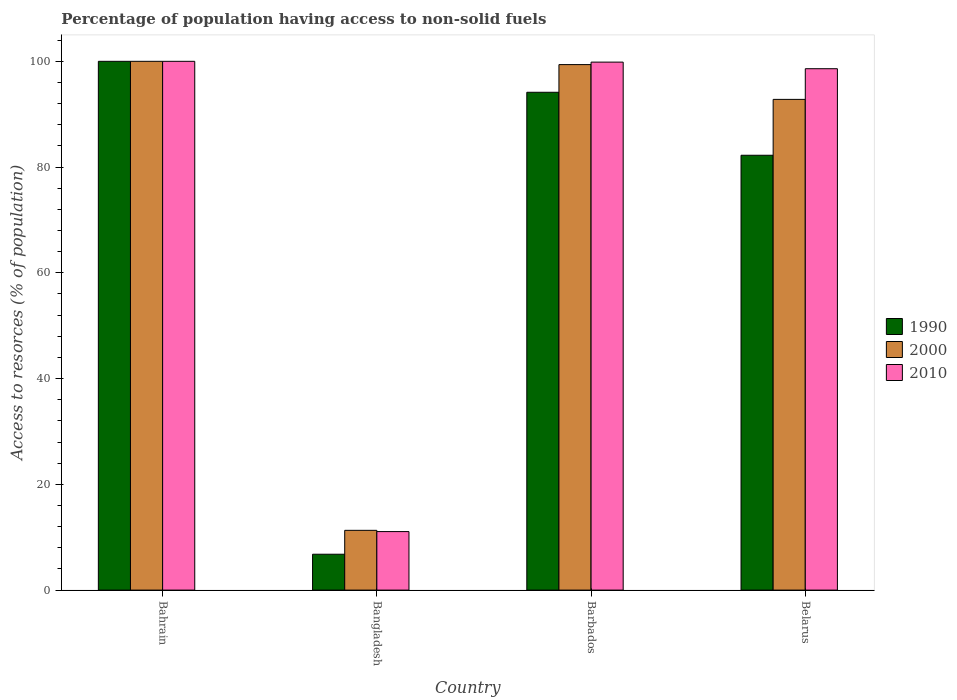How many different coloured bars are there?
Offer a very short reply. 3. How many groups of bars are there?
Provide a succinct answer. 4. How many bars are there on the 3rd tick from the left?
Offer a very short reply. 3. How many bars are there on the 2nd tick from the right?
Your answer should be compact. 3. What is the label of the 3rd group of bars from the left?
Make the answer very short. Barbados. What is the percentage of population having access to non-solid fuels in 2010 in Barbados?
Your answer should be very brief. 99.85. Across all countries, what is the minimum percentage of population having access to non-solid fuels in 1990?
Offer a terse response. 6.78. In which country was the percentage of population having access to non-solid fuels in 2010 maximum?
Your answer should be very brief. Bahrain. What is the total percentage of population having access to non-solid fuels in 1990 in the graph?
Ensure brevity in your answer.  283.16. What is the difference between the percentage of population having access to non-solid fuels in 2000 in Bangladesh and that in Belarus?
Make the answer very short. -81.5. What is the difference between the percentage of population having access to non-solid fuels in 2010 in Bahrain and the percentage of population having access to non-solid fuels in 1990 in Belarus?
Give a very brief answer. 17.76. What is the average percentage of population having access to non-solid fuels in 2010 per country?
Your answer should be compact. 77.38. What is the difference between the percentage of population having access to non-solid fuels of/in 1990 and percentage of population having access to non-solid fuels of/in 2000 in Bangladesh?
Offer a very short reply. -4.52. What is the ratio of the percentage of population having access to non-solid fuels in 1990 in Bangladesh to that in Barbados?
Your answer should be very brief. 0.07. Is the percentage of population having access to non-solid fuels in 1990 in Barbados less than that in Belarus?
Your answer should be very brief. No. Is the difference between the percentage of population having access to non-solid fuels in 1990 in Bahrain and Barbados greater than the difference between the percentage of population having access to non-solid fuels in 2000 in Bahrain and Barbados?
Make the answer very short. Yes. What is the difference between the highest and the second highest percentage of population having access to non-solid fuels in 1990?
Provide a short and direct response. -17.76. What is the difference between the highest and the lowest percentage of population having access to non-solid fuels in 2000?
Provide a succinct answer. 88.7. In how many countries, is the percentage of population having access to non-solid fuels in 2000 greater than the average percentage of population having access to non-solid fuels in 2000 taken over all countries?
Give a very brief answer. 3. What does the 2nd bar from the left in Barbados represents?
Your answer should be compact. 2000. Is it the case that in every country, the sum of the percentage of population having access to non-solid fuels in 2010 and percentage of population having access to non-solid fuels in 2000 is greater than the percentage of population having access to non-solid fuels in 1990?
Your answer should be compact. Yes. Are all the bars in the graph horizontal?
Your answer should be compact. No. How many countries are there in the graph?
Offer a terse response. 4. Does the graph contain any zero values?
Provide a succinct answer. No. What is the title of the graph?
Make the answer very short. Percentage of population having access to non-solid fuels. What is the label or title of the X-axis?
Provide a succinct answer. Country. What is the label or title of the Y-axis?
Your answer should be very brief. Access to resorces (% of population). What is the Access to resorces (% of population) of 2010 in Bahrain?
Provide a succinct answer. 100. What is the Access to resorces (% of population) in 1990 in Bangladesh?
Your answer should be very brief. 6.78. What is the Access to resorces (% of population) of 2000 in Bangladesh?
Your answer should be very brief. 11.3. What is the Access to resorces (% of population) in 2010 in Bangladesh?
Give a very brief answer. 11.07. What is the Access to resorces (% of population) of 1990 in Barbados?
Your answer should be very brief. 94.14. What is the Access to resorces (% of population) in 2000 in Barbados?
Your response must be concise. 99.38. What is the Access to resorces (% of population) in 2010 in Barbados?
Provide a short and direct response. 99.85. What is the Access to resorces (% of population) of 1990 in Belarus?
Give a very brief answer. 82.24. What is the Access to resorces (% of population) of 2000 in Belarus?
Ensure brevity in your answer.  92.8. What is the Access to resorces (% of population) of 2010 in Belarus?
Make the answer very short. 98.6. Across all countries, what is the minimum Access to resorces (% of population) in 1990?
Ensure brevity in your answer.  6.78. Across all countries, what is the minimum Access to resorces (% of population) in 2000?
Your response must be concise. 11.3. Across all countries, what is the minimum Access to resorces (% of population) of 2010?
Provide a succinct answer. 11.07. What is the total Access to resorces (% of population) of 1990 in the graph?
Your answer should be very brief. 283.16. What is the total Access to resorces (% of population) in 2000 in the graph?
Your answer should be very brief. 303.48. What is the total Access to resorces (% of population) in 2010 in the graph?
Your answer should be very brief. 309.51. What is the difference between the Access to resorces (% of population) in 1990 in Bahrain and that in Bangladesh?
Make the answer very short. 93.22. What is the difference between the Access to resorces (% of population) of 2000 in Bahrain and that in Bangladesh?
Offer a very short reply. 88.7. What is the difference between the Access to resorces (% of population) in 2010 in Bahrain and that in Bangladesh?
Make the answer very short. 88.93. What is the difference between the Access to resorces (% of population) in 1990 in Bahrain and that in Barbados?
Your answer should be very brief. 5.86. What is the difference between the Access to resorces (% of population) of 2000 in Bahrain and that in Barbados?
Give a very brief answer. 0.62. What is the difference between the Access to resorces (% of population) of 2010 in Bahrain and that in Barbados?
Offer a terse response. 0.15. What is the difference between the Access to resorces (% of population) in 1990 in Bahrain and that in Belarus?
Offer a very short reply. 17.76. What is the difference between the Access to resorces (% of population) in 2000 in Bahrain and that in Belarus?
Make the answer very short. 7.2. What is the difference between the Access to resorces (% of population) in 2010 in Bahrain and that in Belarus?
Provide a short and direct response. 1.4. What is the difference between the Access to resorces (% of population) of 1990 in Bangladesh and that in Barbados?
Your answer should be compact. -87.36. What is the difference between the Access to resorces (% of population) in 2000 in Bangladesh and that in Barbados?
Keep it short and to the point. -88.08. What is the difference between the Access to resorces (% of population) of 2010 in Bangladesh and that in Barbados?
Provide a short and direct response. -88.78. What is the difference between the Access to resorces (% of population) of 1990 in Bangladesh and that in Belarus?
Give a very brief answer. -75.45. What is the difference between the Access to resorces (% of population) in 2000 in Bangladesh and that in Belarus?
Offer a terse response. -81.5. What is the difference between the Access to resorces (% of population) in 2010 in Bangladesh and that in Belarus?
Give a very brief answer. -87.53. What is the difference between the Access to resorces (% of population) of 1990 in Barbados and that in Belarus?
Offer a terse response. 11.91. What is the difference between the Access to resorces (% of population) in 2000 in Barbados and that in Belarus?
Make the answer very short. 6.58. What is the difference between the Access to resorces (% of population) of 2010 in Barbados and that in Belarus?
Your answer should be very brief. 1.25. What is the difference between the Access to resorces (% of population) in 1990 in Bahrain and the Access to resorces (% of population) in 2000 in Bangladesh?
Give a very brief answer. 88.7. What is the difference between the Access to resorces (% of population) in 1990 in Bahrain and the Access to resorces (% of population) in 2010 in Bangladesh?
Your response must be concise. 88.93. What is the difference between the Access to resorces (% of population) of 2000 in Bahrain and the Access to resorces (% of population) of 2010 in Bangladesh?
Your answer should be compact. 88.93. What is the difference between the Access to resorces (% of population) in 1990 in Bahrain and the Access to resorces (% of population) in 2000 in Barbados?
Offer a terse response. 0.62. What is the difference between the Access to resorces (% of population) of 1990 in Bahrain and the Access to resorces (% of population) of 2010 in Barbados?
Your response must be concise. 0.15. What is the difference between the Access to resorces (% of population) in 2000 in Bahrain and the Access to resorces (% of population) in 2010 in Barbados?
Keep it short and to the point. 0.15. What is the difference between the Access to resorces (% of population) in 1990 in Bahrain and the Access to resorces (% of population) in 2000 in Belarus?
Your response must be concise. 7.2. What is the difference between the Access to resorces (% of population) of 1990 in Bahrain and the Access to resorces (% of population) of 2010 in Belarus?
Make the answer very short. 1.4. What is the difference between the Access to resorces (% of population) in 2000 in Bahrain and the Access to resorces (% of population) in 2010 in Belarus?
Offer a very short reply. 1.4. What is the difference between the Access to resorces (% of population) of 1990 in Bangladesh and the Access to resorces (% of population) of 2000 in Barbados?
Keep it short and to the point. -92.6. What is the difference between the Access to resorces (% of population) in 1990 in Bangladesh and the Access to resorces (% of population) in 2010 in Barbados?
Your response must be concise. -93.06. What is the difference between the Access to resorces (% of population) of 2000 in Bangladesh and the Access to resorces (% of population) of 2010 in Barbados?
Make the answer very short. -88.55. What is the difference between the Access to resorces (% of population) in 1990 in Bangladesh and the Access to resorces (% of population) in 2000 in Belarus?
Keep it short and to the point. -86.02. What is the difference between the Access to resorces (% of population) of 1990 in Bangladesh and the Access to resorces (% of population) of 2010 in Belarus?
Your response must be concise. -91.82. What is the difference between the Access to resorces (% of population) in 2000 in Bangladesh and the Access to resorces (% of population) in 2010 in Belarus?
Your response must be concise. -87.3. What is the difference between the Access to resorces (% of population) of 1990 in Barbados and the Access to resorces (% of population) of 2000 in Belarus?
Provide a succinct answer. 1.34. What is the difference between the Access to resorces (% of population) in 1990 in Barbados and the Access to resorces (% of population) in 2010 in Belarus?
Provide a succinct answer. -4.46. What is the difference between the Access to resorces (% of population) in 2000 in Barbados and the Access to resorces (% of population) in 2010 in Belarus?
Your response must be concise. 0.78. What is the average Access to resorces (% of population) in 1990 per country?
Provide a short and direct response. 70.79. What is the average Access to resorces (% of population) of 2000 per country?
Make the answer very short. 75.87. What is the average Access to resorces (% of population) in 2010 per country?
Your answer should be compact. 77.38. What is the difference between the Access to resorces (% of population) in 1990 and Access to resorces (% of population) in 2000 in Bahrain?
Offer a very short reply. 0. What is the difference between the Access to resorces (% of population) in 1990 and Access to resorces (% of population) in 2010 in Bahrain?
Offer a terse response. 0. What is the difference between the Access to resorces (% of population) in 2000 and Access to resorces (% of population) in 2010 in Bahrain?
Give a very brief answer. 0. What is the difference between the Access to resorces (% of population) in 1990 and Access to resorces (% of population) in 2000 in Bangladesh?
Give a very brief answer. -4.52. What is the difference between the Access to resorces (% of population) of 1990 and Access to resorces (% of population) of 2010 in Bangladesh?
Offer a terse response. -4.28. What is the difference between the Access to resorces (% of population) in 2000 and Access to resorces (% of population) in 2010 in Bangladesh?
Offer a terse response. 0.24. What is the difference between the Access to resorces (% of population) of 1990 and Access to resorces (% of population) of 2000 in Barbados?
Your answer should be compact. -5.23. What is the difference between the Access to resorces (% of population) in 1990 and Access to resorces (% of population) in 2010 in Barbados?
Make the answer very short. -5.7. What is the difference between the Access to resorces (% of population) of 2000 and Access to resorces (% of population) of 2010 in Barbados?
Ensure brevity in your answer.  -0.47. What is the difference between the Access to resorces (% of population) of 1990 and Access to resorces (% of population) of 2000 in Belarus?
Ensure brevity in your answer.  -10.56. What is the difference between the Access to resorces (% of population) of 1990 and Access to resorces (% of population) of 2010 in Belarus?
Keep it short and to the point. -16.36. What is the difference between the Access to resorces (% of population) of 2000 and Access to resorces (% of population) of 2010 in Belarus?
Provide a short and direct response. -5.8. What is the ratio of the Access to resorces (% of population) of 1990 in Bahrain to that in Bangladesh?
Make the answer very short. 14.74. What is the ratio of the Access to resorces (% of population) of 2000 in Bahrain to that in Bangladesh?
Your answer should be very brief. 8.85. What is the ratio of the Access to resorces (% of population) in 2010 in Bahrain to that in Bangladesh?
Give a very brief answer. 9.04. What is the ratio of the Access to resorces (% of population) in 1990 in Bahrain to that in Barbados?
Make the answer very short. 1.06. What is the ratio of the Access to resorces (% of population) in 1990 in Bahrain to that in Belarus?
Offer a very short reply. 1.22. What is the ratio of the Access to resorces (% of population) in 2000 in Bahrain to that in Belarus?
Give a very brief answer. 1.08. What is the ratio of the Access to resorces (% of population) in 2010 in Bahrain to that in Belarus?
Your answer should be very brief. 1.01. What is the ratio of the Access to resorces (% of population) of 1990 in Bangladesh to that in Barbados?
Provide a short and direct response. 0.07. What is the ratio of the Access to resorces (% of population) in 2000 in Bangladesh to that in Barbados?
Offer a terse response. 0.11. What is the ratio of the Access to resorces (% of population) of 2010 in Bangladesh to that in Barbados?
Make the answer very short. 0.11. What is the ratio of the Access to resorces (% of population) in 1990 in Bangladesh to that in Belarus?
Make the answer very short. 0.08. What is the ratio of the Access to resorces (% of population) in 2000 in Bangladesh to that in Belarus?
Keep it short and to the point. 0.12. What is the ratio of the Access to resorces (% of population) of 2010 in Bangladesh to that in Belarus?
Keep it short and to the point. 0.11. What is the ratio of the Access to resorces (% of population) of 1990 in Barbados to that in Belarus?
Give a very brief answer. 1.14. What is the ratio of the Access to resorces (% of population) of 2000 in Barbados to that in Belarus?
Ensure brevity in your answer.  1.07. What is the ratio of the Access to resorces (% of population) in 2010 in Barbados to that in Belarus?
Your response must be concise. 1.01. What is the difference between the highest and the second highest Access to resorces (% of population) of 1990?
Provide a short and direct response. 5.86. What is the difference between the highest and the second highest Access to resorces (% of population) in 2000?
Provide a short and direct response. 0.62. What is the difference between the highest and the second highest Access to resorces (% of population) of 2010?
Provide a short and direct response. 0.15. What is the difference between the highest and the lowest Access to resorces (% of population) of 1990?
Offer a very short reply. 93.22. What is the difference between the highest and the lowest Access to resorces (% of population) in 2000?
Keep it short and to the point. 88.7. What is the difference between the highest and the lowest Access to resorces (% of population) in 2010?
Offer a terse response. 88.93. 